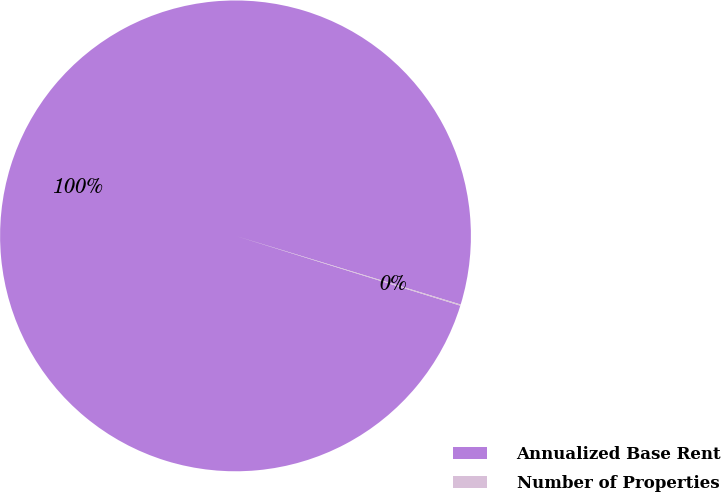Convert chart. <chart><loc_0><loc_0><loc_500><loc_500><pie_chart><fcel>Annualized Base Rent<fcel>Number of Properties<nl><fcel>99.92%<fcel>0.08%<nl></chart> 